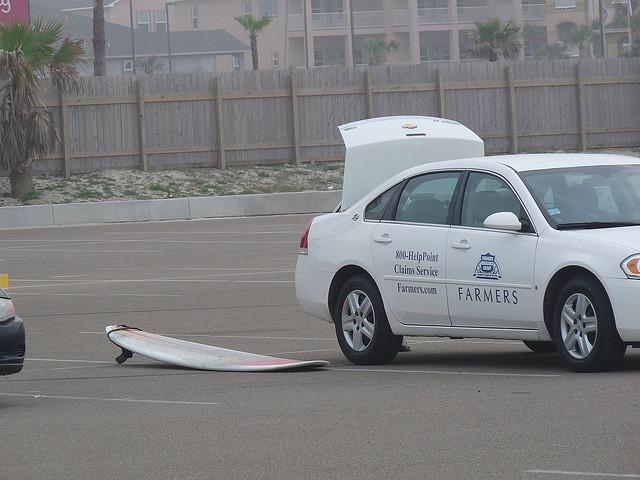How many bikes have baskets?
Give a very brief answer. 0. 